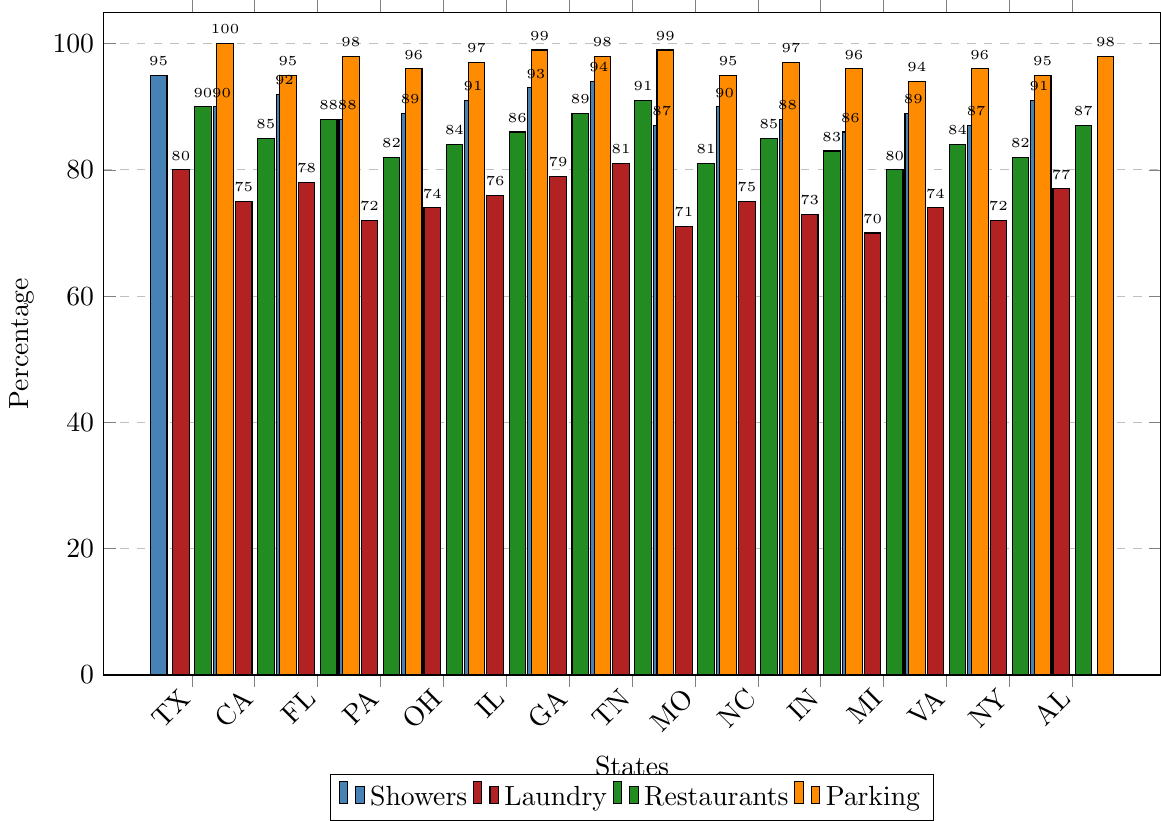What state has the highest percentage of showers? By looking at the figure and identifying the tallest blue bar, we can see that Tennessee (TN) has the highest percentage of showers at 94%.
Answer: Tennessee (TN) Which state has the lowest percentage of laundry facilities, and what is the percentage? Identify the shortest red bar in the figure, representing laundry facilities. Missouri (MO) has the lowest percentage at 71%.
Answer: Missouri (MO), 71% In which states is the percentage of restaurants exactly 88% or higher? Check the height of the green bars that are at or above the 88% mark. Texas (TX), Florida (FL), Georgia (GA), Tennessee (TN), and Alabama (AL) meet this criterion.
Answer: Texas (TX), Florida (FL), Georgia (GA), Tennessee (TN), Alabama (AL) Compare the percentages of parking in Texas (TX) and California (CA). Which one is higher and by how much? The parking percentage in Texas (TX) is 100% and in California (CA) it is 95%. The difference is 100 - 95 = 5%. Texas (TX) has a higher percentage by 5%.
Answer: Texas (TX) by 5% Which state has a higher percentage of showers, Texas (TX) or Indiana (IN), and what is the difference? Texas (TX) has 95% showers and Indiana (IN) has 88% showers. The difference is 95 - 88 = 7%. Texas (TX) has a higher percentage by 7%.
Answer: Texas (TX) by 7% What's the average percentage of laundry facilities across all states? Sum the percentages of laundry facilities and divide by the number of states: (80+75+78+72+74+76+79+81+71+75+73+70+74+72+77)/15 = 75%
Answer: 75% In which states do the percentages of parking and restaurants both exceed 95%? Identify the bars where both green (restaurants) and orange (parking) exceed 95%. Texas (TX), Illinois (IL), Tennessee (TN), and Alabama (AL) have both above 95%.
Answer: Texas (TX), Illinois (IL), Tennessee (TN), Alabama (AL) Which state has the lowest percentage of parking, and what is the percentage? Identify the shortest orange bar in the figure. Michigan (MI) has the lowest percentage at 94%.
Answer: Michigan (MI), 94% Looking at the visual colors, how many states have matching (equal) percentages for showers and laundry? Check the paired heights of the blue and red bars for each state. None of the states have matching percentages for showers and laundry.
Answer: 0 states 